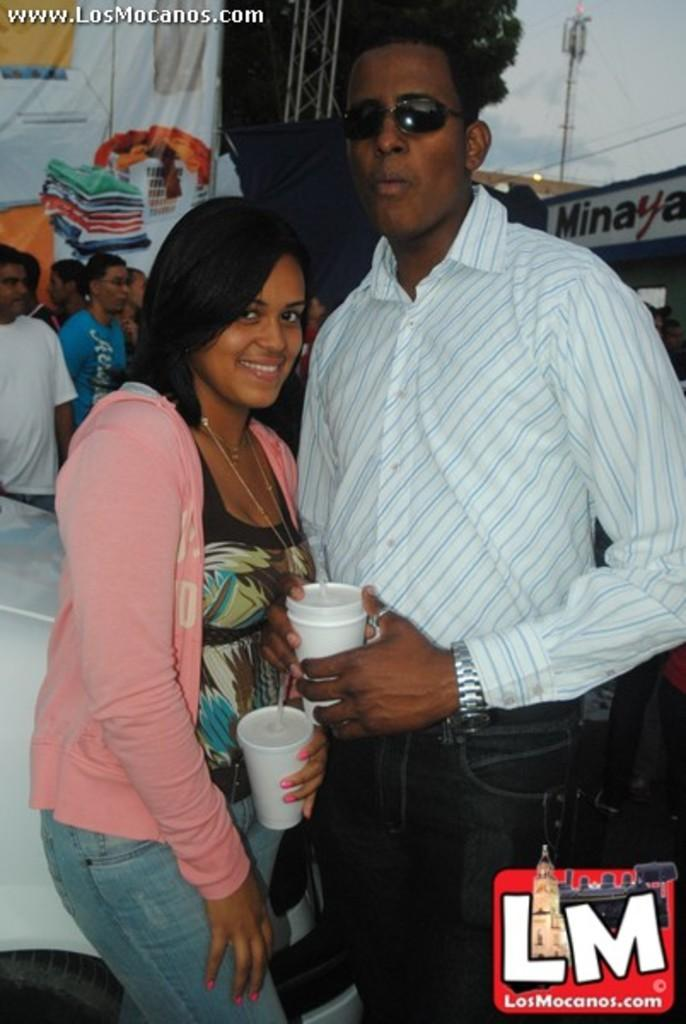How many people are present in the image? There are two people, a man and a woman, present in the image. What are the man and the woman doing in the image? They are smiling, holding cups, and posing for the camera. Are there any other people visible in the image? Yes, there are other people standing behind them. What type of collar can be seen on the cake in the image? There is no cake or collar present in the image. What role did the man and the woman play in the war depicted in the image? There is no war or any indication of war in the image. 